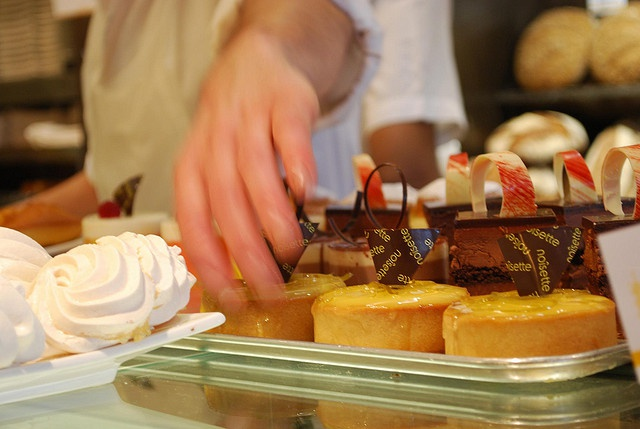Describe the objects in this image and their specific colors. I can see people in maroon, tan, gray, and darkgray tones, cake in maroon, orange, and red tones, cake in maroon, beige, and tan tones, cake in maroon, orange, and red tones, and cake in maroon, black, and brown tones in this image. 